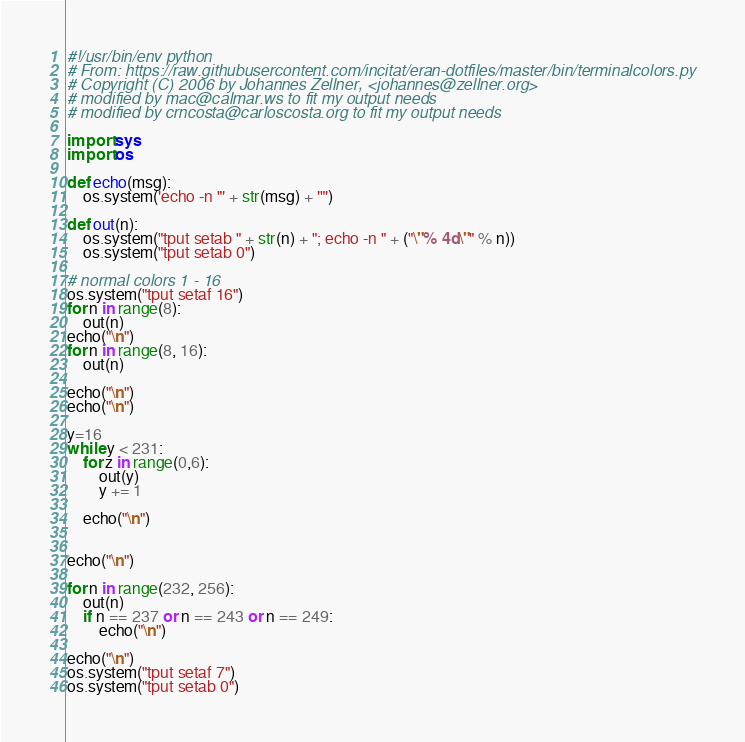Convert code to text. <code><loc_0><loc_0><loc_500><loc_500><_Python_>#!/usr/bin/env python
# From: https://raw.githubusercontent.com/incitat/eran-dotfiles/master/bin/terminalcolors.py
# Copyright (C) 2006 by Johannes Zellner, <johannes@zellner.org>
# modified by mac@calmar.ws to fit my output needs
# modified by crncosta@carloscosta.org to fit my output needs

import sys
import os

def echo(msg):
    os.system('echo -n "' + str(msg) + '"')

def out(n):
    os.system("tput setab " + str(n) + "; echo -n " + ("\"% 4d\"" % n))
    os.system("tput setab 0")

# normal colors 1 - 16
os.system("tput setaf 16")
for n in range(8):
    out(n)
echo("\n")
for n in range(8, 16):
    out(n)

echo("\n")
echo("\n")

y=16
while y < 231:
    for z in range(0,6):
        out(y)
        y += 1

    echo("\n")


echo("\n")

for n in range(232, 256):
    out(n)
    if n == 237 or n == 243 or n == 249:
        echo("\n")

echo("\n")
os.system("tput setaf 7")
os.system("tput setab 0")
</code> 